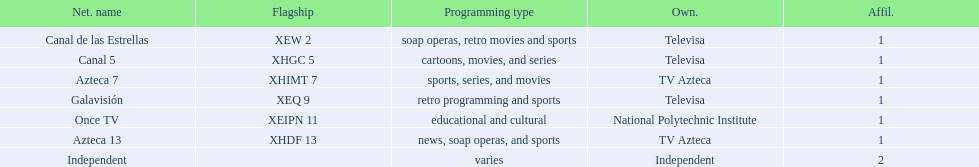What is the number of affiliates associated with galavision? 1. 